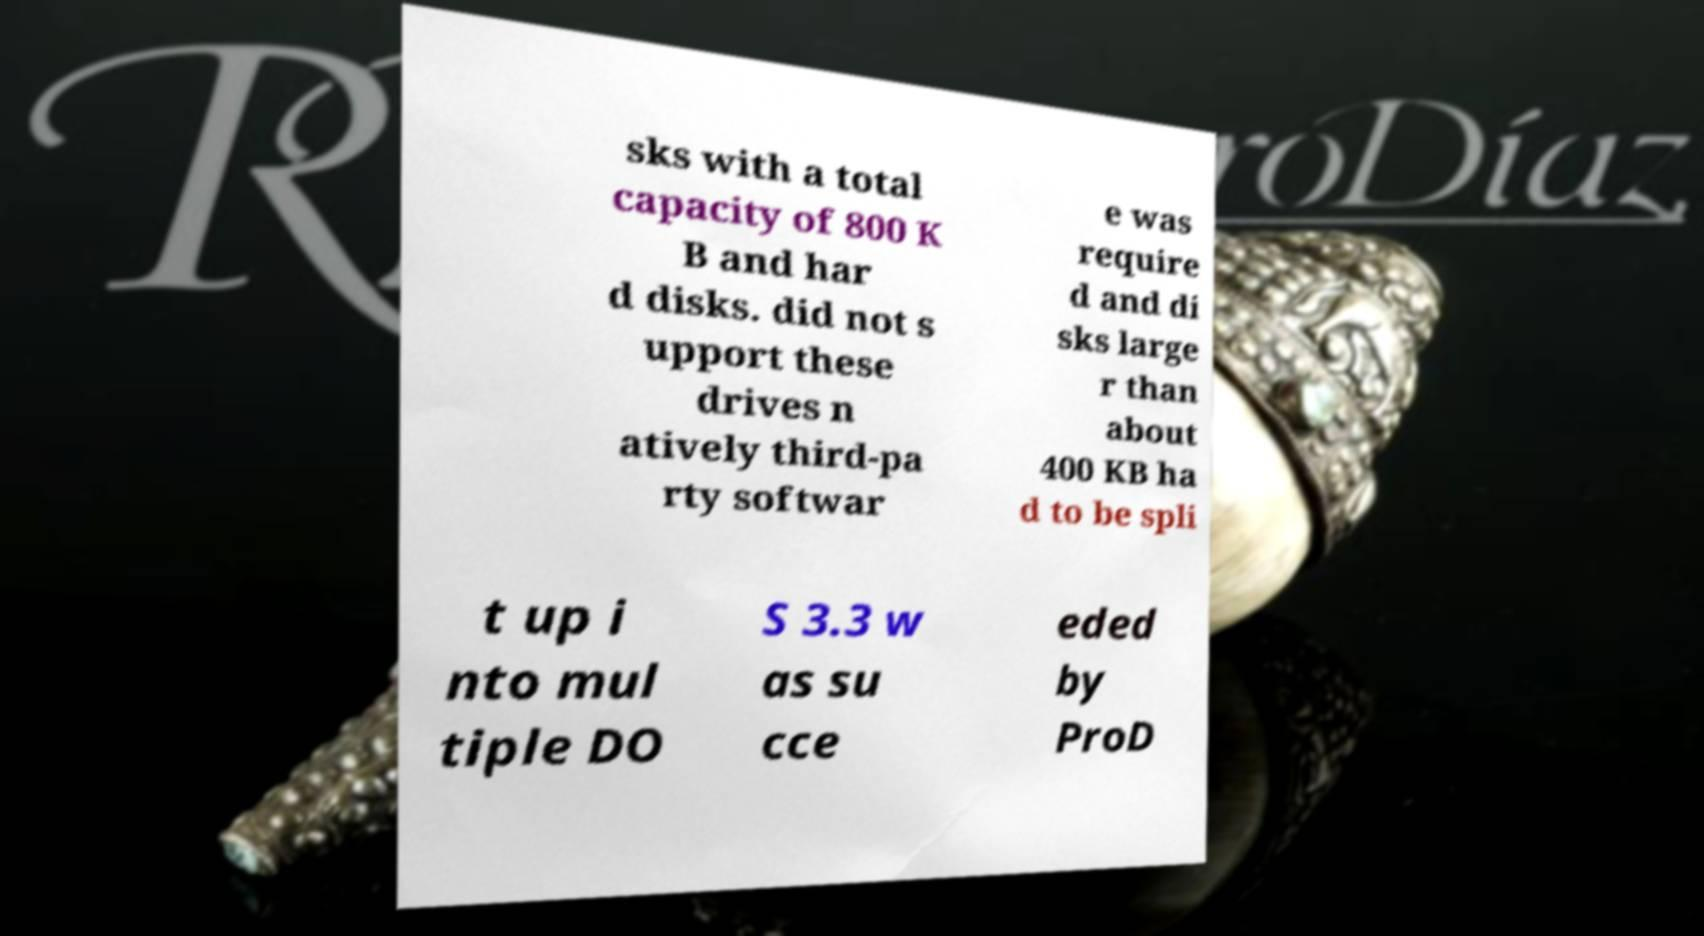Please identify and transcribe the text found in this image. sks with a total capacity of 800 K B and har d disks. did not s upport these drives n atively third-pa rty softwar e was require d and di sks large r than about 400 KB ha d to be spli t up i nto mul tiple DO S 3.3 w as su cce eded by ProD 